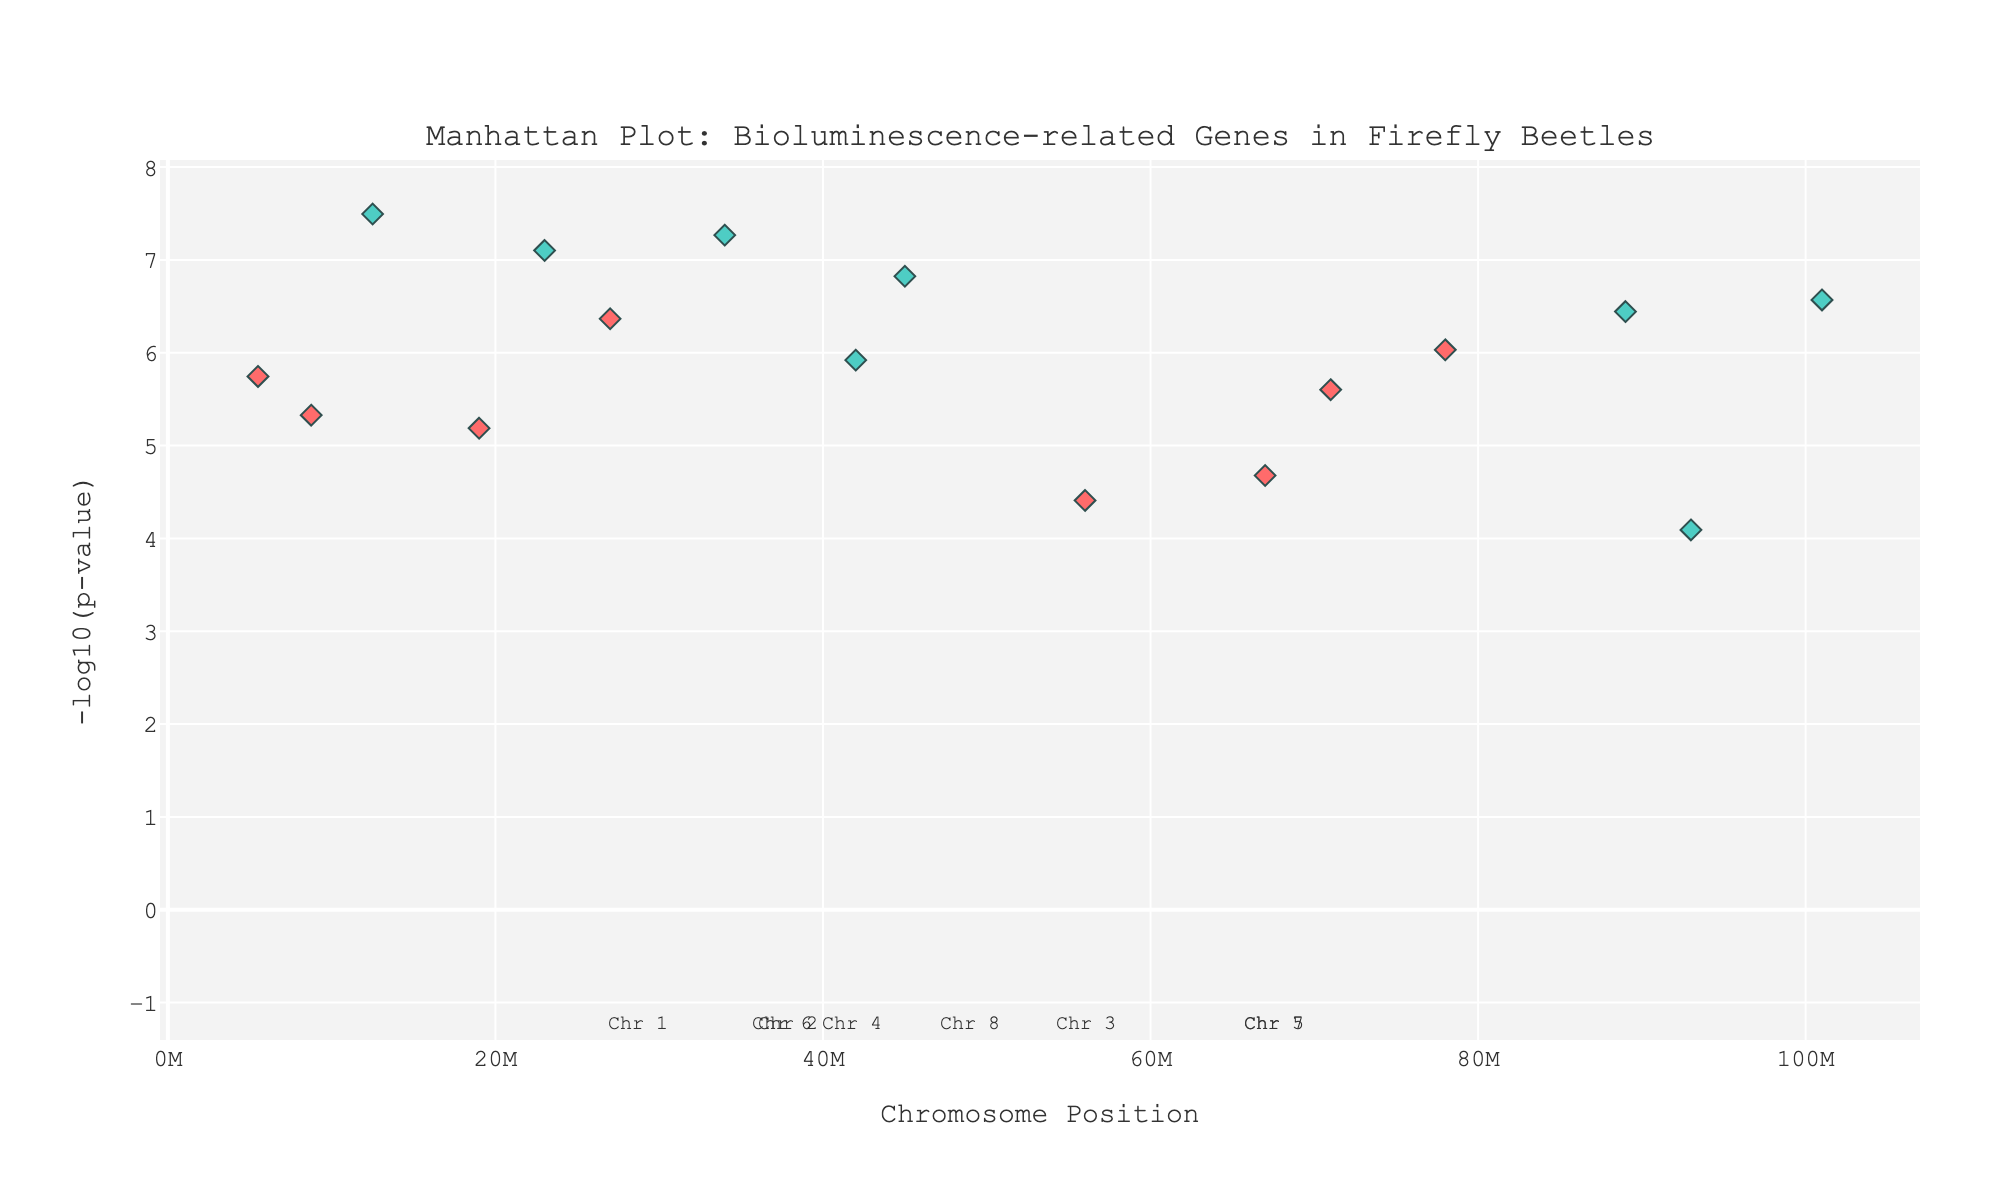What does the title of the plot indicate? The title 'Manhattan Plot: Bioluminescence-related Genes in Firefly Beetles' indicates that the plot visualizes the p-values of genetic variants related to bioluminescence in firefly beetles. This helps us identify significant genomic regions associated with bioluminescence.
Answer: Manhattan Plot: Bioluminescence-related Genes in Firefly Beetles How are significant genes indicated in the plot? Significant genes are indicated by points at higher positions on the y-axis as they have lower p-values. These points are marked by higher values of '-log10(p-value)'.
Answer: By higher points on the y-axis Which gene has the highest significance shown in the plot? To determine the highest significance, we look for the highest point on the y-axis. The highest point corresponds to the gene 'Luciferase' on Chromosome 1 with a -log10(p-value) value above 7.
Answer: Luciferase Which chromosome has the gene with the second highest significance? The second highest point on the y-axis represents the gene with the next highest significance. This point corresponds to the gene 'Luciferase-like oxidoreductase' on Chromosome 3.
Answer: Chromosome 3 List all the genes on Chromosome 5. To identify these genes, we locate all data points associated with Chromosome 5, which are 'Luciferase-like monooxygenase' and 'ATP-dependent luciferase'.
Answer: Luciferase-like monooxygenase, ATP-dependent luciferase What is the y-axis value for the gene 'Luciferin 4-monooxygenase'? The y-axis represents the -log10(p-value). The gene 'Luciferin 4-monooxygenase' on Chromosome 1 has a p-value of 1.5e-7, resulting in a -log10(p-value) of approximately 6.82.
Answer: Approximately 6.82 Among 'Fatty acyl-CoA reductase' and 'Luciferin-regenerating enzyme', which has a more significant p-value? Comparing their y-axis positions, the gene with a higher -log10(p-value) is more significant. 'Fatty acyl-CoA reductase' has a -log10(p-value) of around 5.74, while 'Luciferin-regenerating enzyme' has a -log10(p-value) of approximately 6.03, making 'Luciferin-regenerating enzyme' more significant.
Answer: Luciferin-regenerating enzyme What is the average -log10(p-value) for genes on Chromosome 2? To find this, average the -log10(p-values) of 'Acyl-CoA thioesterase' and 'Nitrilase'. Their -log10(p-values) are approximately 5.33 and 4.68, respectively. The average is (5.33 + 4.68) / 2 ≈ 5.01.
Answer: Approximately 5.01 Comparing Chromosome 1 and Chromosome 7, which one has more significant genes below the threshold of 1e-6? Identify genes below the threshold on each chromosome. Chromosome 1 has two genes (both below the threshold) while Chromosome 7 has one gene below the threshold. Thus, Chromosome 1 has more significant genes.
Answer: Chromosome 1 